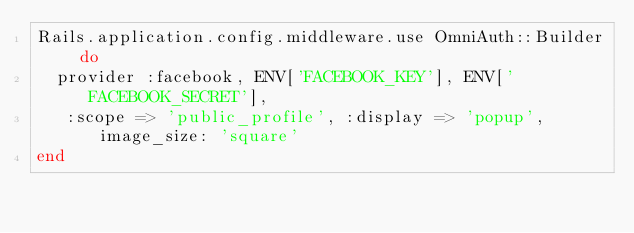<code> <loc_0><loc_0><loc_500><loc_500><_Ruby_>Rails.application.config.middleware.use OmniAuth::Builder do
  provider :facebook, ENV['FACEBOOK_KEY'], ENV['FACEBOOK_SECRET'], 
   :scope => 'public_profile', :display => 'popup', image_size: 'square'
end</code> 